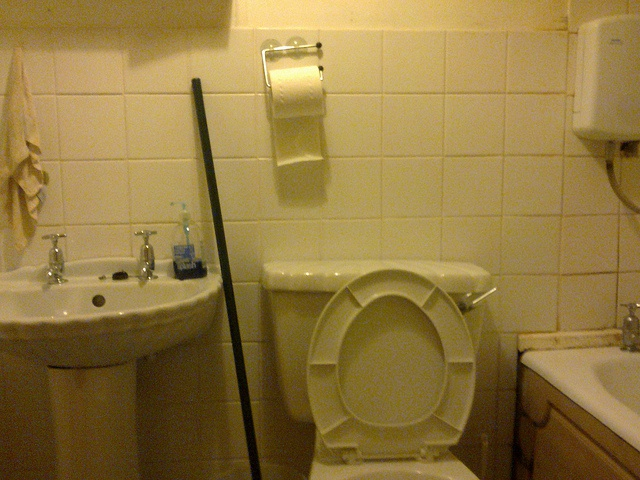Describe the objects in this image and their specific colors. I can see toilet in olive tones, sink in olive, tan, and maroon tones, and bottle in olive, black, and gray tones in this image. 